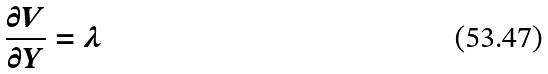Convert formula to latex. <formula><loc_0><loc_0><loc_500><loc_500>\frac { \partial V } { \partial Y } = \lambda</formula> 